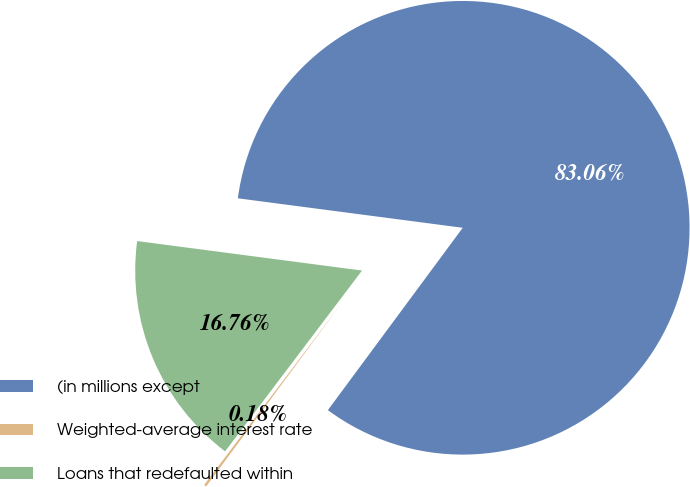<chart> <loc_0><loc_0><loc_500><loc_500><pie_chart><fcel>(in millions except<fcel>Weighted-average interest rate<fcel>Loans that redefaulted within<nl><fcel>83.06%<fcel>0.18%<fcel>16.76%<nl></chart> 